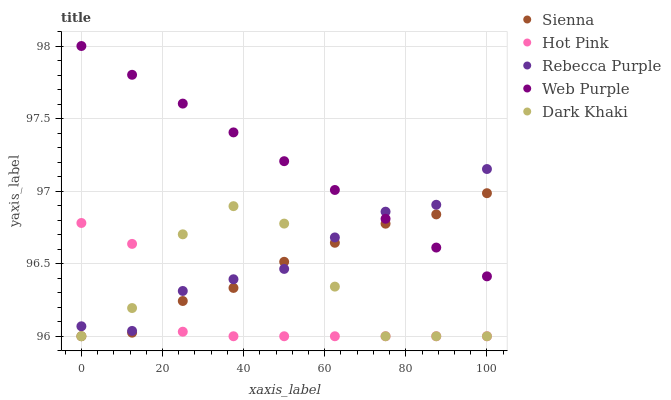Does Hot Pink have the minimum area under the curve?
Answer yes or no. Yes. Does Web Purple have the maximum area under the curve?
Answer yes or no. Yes. Does Dark Khaki have the minimum area under the curve?
Answer yes or no. No. Does Dark Khaki have the maximum area under the curve?
Answer yes or no. No. Is Web Purple the smoothest?
Answer yes or no. Yes. Is Dark Khaki the roughest?
Answer yes or no. Yes. Is Dark Khaki the smoothest?
Answer yes or no. No. Is Web Purple the roughest?
Answer yes or no. No. Does Sienna have the lowest value?
Answer yes or no. Yes. Does Web Purple have the lowest value?
Answer yes or no. No. Does Web Purple have the highest value?
Answer yes or no. Yes. Does Dark Khaki have the highest value?
Answer yes or no. No. Is Dark Khaki less than Web Purple?
Answer yes or no. Yes. Is Web Purple greater than Hot Pink?
Answer yes or no. Yes. Does Sienna intersect Dark Khaki?
Answer yes or no. Yes. Is Sienna less than Dark Khaki?
Answer yes or no. No. Is Sienna greater than Dark Khaki?
Answer yes or no. No. Does Dark Khaki intersect Web Purple?
Answer yes or no. No. 